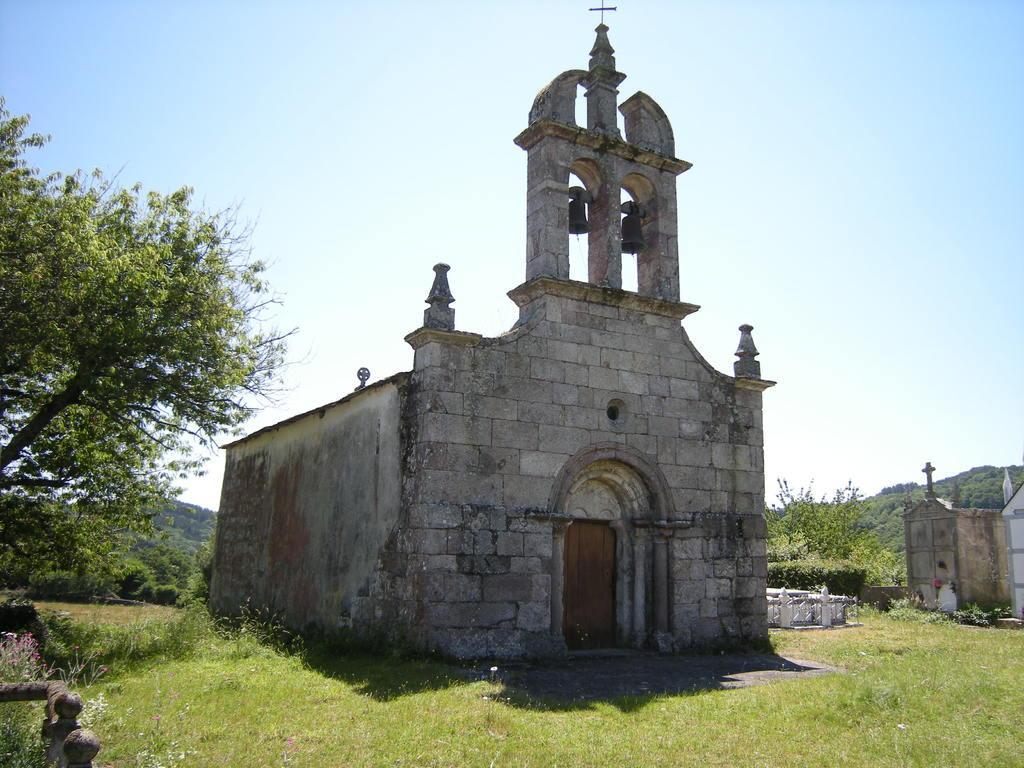Can you describe this image briefly? In this image I can see a building in gray and white color. Background I can see trees in green color and sky is in white and blue color. 